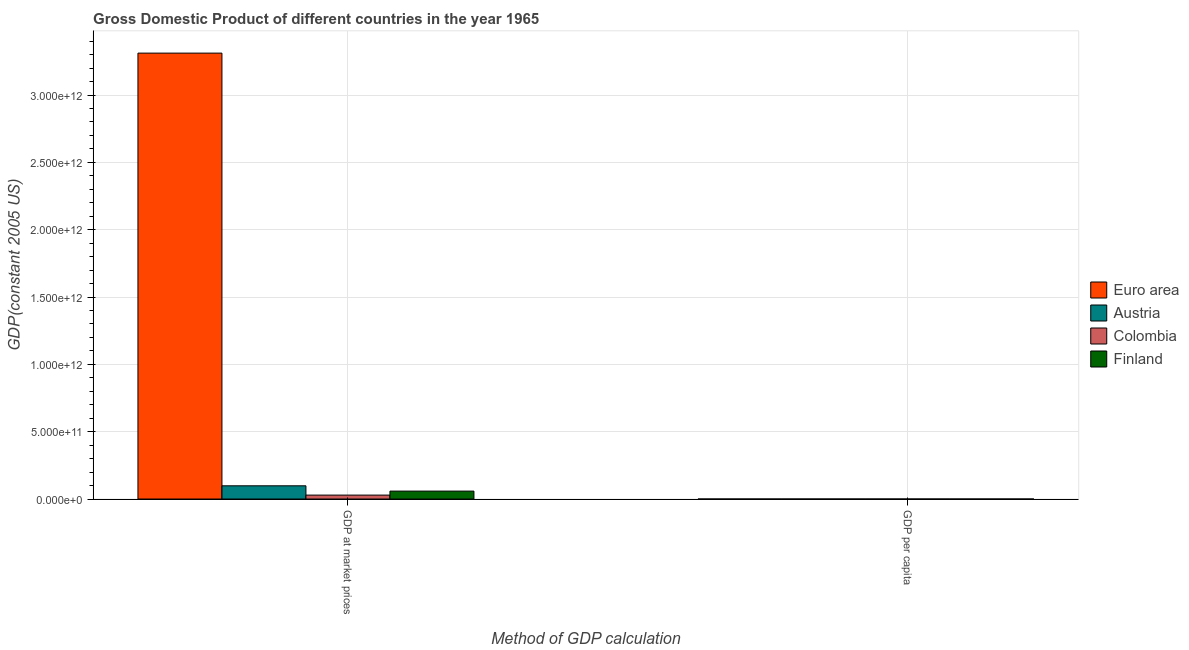Are the number of bars on each tick of the X-axis equal?
Your response must be concise. Yes. How many bars are there on the 1st tick from the left?
Your answer should be compact. 4. What is the label of the 2nd group of bars from the left?
Offer a very short reply. GDP per capita. What is the gdp per capita in Austria?
Keep it short and to the point. 1.35e+04. Across all countries, what is the maximum gdp per capita?
Provide a succinct answer. 1.35e+04. Across all countries, what is the minimum gdp per capita?
Make the answer very short. 1523.6. In which country was the gdp at market prices maximum?
Make the answer very short. Euro area. In which country was the gdp per capita minimum?
Make the answer very short. Colombia. What is the total gdp at market prices in the graph?
Ensure brevity in your answer.  3.50e+12. What is the difference between the gdp at market prices in Austria and that in Colombia?
Provide a short and direct response. 6.91e+1. What is the difference between the gdp at market prices in Colombia and the gdp per capita in Finland?
Provide a succinct answer. 2.92e+1. What is the average gdp per capita per country?
Your response must be concise. 9963.43. What is the difference between the gdp at market prices and gdp per capita in Austria?
Provide a succinct answer. 9.83e+1. What is the ratio of the gdp per capita in Euro area to that in Austria?
Your answer should be compact. 0.88. In how many countries, is the gdp per capita greater than the average gdp per capita taken over all countries?
Make the answer very short. 3. What does the 3rd bar from the left in GDP at market prices represents?
Ensure brevity in your answer.  Colombia. What does the 1st bar from the right in GDP per capita represents?
Provide a short and direct response. Finland. How many bars are there?
Provide a succinct answer. 8. How many countries are there in the graph?
Provide a short and direct response. 4. What is the difference between two consecutive major ticks on the Y-axis?
Offer a terse response. 5.00e+11. Does the graph contain grids?
Provide a short and direct response. Yes. Where does the legend appear in the graph?
Your answer should be very brief. Center right. How many legend labels are there?
Your answer should be compact. 4. How are the legend labels stacked?
Keep it short and to the point. Vertical. What is the title of the graph?
Your answer should be very brief. Gross Domestic Product of different countries in the year 1965. What is the label or title of the X-axis?
Your answer should be very brief. Method of GDP calculation. What is the label or title of the Y-axis?
Provide a short and direct response. GDP(constant 2005 US). What is the GDP(constant 2005 US) of Euro area in GDP at market prices?
Provide a short and direct response. 3.31e+12. What is the GDP(constant 2005 US) of Austria in GDP at market prices?
Keep it short and to the point. 9.83e+1. What is the GDP(constant 2005 US) of Colombia in GDP at market prices?
Make the answer very short. 2.92e+1. What is the GDP(constant 2005 US) of Finland in GDP at market prices?
Make the answer very short. 5.89e+1. What is the GDP(constant 2005 US) in Euro area in GDP per capita?
Offer a very short reply. 1.19e+04. What is the GDP(constant 2005 US) in Austria in GDP per capita?
Provide a short and direct response. 1.35e+04. What is the GDP(constant 2005 US) in Colombia in GDP per capita?
Make the answer very short. 1523.6. What is the GDP(constant 2005 US) in Finland in GDP per capita?
Offer a very short reply. 1.29e+04. Across all Method of GDP calculation, what is the maximum GDP(constant 2005 US) in Euro area?
Provide a short and direct response. 3.31e+12. Across all Method of GDP calculation, what is the maximum GDP(constant 2005 US) of Austria?
Your answer should be compact. 9.83e+1. Across all Method of GDP calculation, what is the maximum GDP(constant 2005 US) of Colombia?
Give a very brief answer. 2.92e+1. Across all Method of GDP calculation, what is the maximum GDP(constant 2005 US) of Finland?
Offer a terse response. 5.89e+1. Across all Method of GDP calculation, what is the minimum GDP(constant 2005 US) in Euro area?
Your answer should be compact. 1.19e+04. Across all Method of GDP calculation, what is the minimum GDP(constant 2005 US) in Austria?
Keep it short and to the point. 1.35e+04. Across all Method of GDP calculation, what is the minimum GDP(constant 2005 US) in Colombia?
Ensure brevity in your answer.  1523.6. Across all Method of GDP calculation, what is the minimum GDP(constant 2005 US) in Finland?
Offer a terse response. 1.29e+04. What is the total GDP(constant 2005 US) of Euro area in the graph?
Your response must be concise. 3.31e+12. What is the total GDP(constant 2005 US) in Austria in the graph?
Your response must be concise. 9.83e+1. What is the total GDP(constant 2005 US) in Colombia in the graph?
Offer a very short reply. 2.92e+1. What is the total GDP(constant 2005 US) of Finland in the graph?
Your answer should be very brief. 5.89e+1. What is the difference between the GDP(constant 2005 US) in Euro area in GDP at market prices and that in GDP per capita?
Provide a short and direct response. 3.31e+12. What is the difference between the GDP(constant 2005 US) of Austria in GDP at market prices and that in GDP per capita?
Your answer should be compact. 9.83e+1. What is the difference between the GDP(constant 2005 US) in Colombia in GDP at market prices and that in GDP per capita?
Offer a very short reply. 2.92e+1. What is the difference between the GDP(constant 2005 US) in Finland in GDP at market prices and that in GDP per capita?
Provide a succinct answer. 5.89e+1. What is the difference between the GDP(constant 2005 US) in Euro area in GDP at market prices and the GDP(constant 2005 US) in Austria in GDP per capita?
Give a very brief answer. 3.31e+12. What is the difference between the GDP(constant 2005 US) of Euro area in GDP at market prices and the GDP(constant 2005 US) of Colombia in GDP per capita?
Your response must be concise. 3.31e+12. What is the difference between the GDP(constant 2005 US) in Euro area in GDP at market prices and the GDP(constant 2005 US) in Finland in GDP per capita?
Keep it short and to the point. 3.31e+12. What is the difference between the GDP(constant 2005 US) in Austria in GDP at market prices and the GDP(constant 2005 US) in Colombia in GDP per capita?
Your answer should be compact. 9.83e+1. What is the difference between the GDP(constant 2005 US) of Austria in GDP at market prices and the GDP(constant 2005 US) of Finland in GDP per capita?
Offer a terse response. 9.83e+1. What is the difference between the GDP(constant 2005 US) of Colombia in GDP at market prices and the GDP(constant 2005 US) of Finland in GDP per capita?
Offer a terse response. 2.92e+1. What is the average GDP(constant 2005 US) in Euro area per Method of GDP calculation?
Offer a terse response. 1.66e+12. What is the average GDP(constant 2005 US) in Austria per Method of GDP calculation?
Your response must be concise. 4.91e+1. What is the average GDP(constant 2005 US) in Colombia per Method of GDP calculation?
Provide a succinct answer. 1.46e+1. What is the average GDP(constant 2005 US) in Finland per Method of GDP calculation?
Provide a short and direct response. 2.94e+1. What is the difference between the GDP(constant 2005 US) in Euro area and GDP(constant 2005 US) in Austria in GDP at market prices?
Your response must be concise. 3.21e+12. What is the difference between the GDP(constant 2005 US) of Euro area and GDP(constant 2005 US) of Colombia in GDP at market prices?
Your response must be concise. 3.28e+12. What is the difference between the GDP(constant 2005 US) of Euro area and GDP(constant 2005 US) of Finland in GDP at market prices?
Your answer should be compact. 3.25e+12. What is the difference between the GDP(constant 2005 US) in Austria and GDP(constant 2005 US) in Colombia in GDP at market prices?
Make the answer very short. 6.91e+1. What is the difference between the GDP(constant 2005 US) in Austria and GDP(constant 2005 US) in Finland in GDP at market prices?
Provide a short and direct response. 3.94e+1. What is the difference between the GDP(constant 2005 US) in Colombia and GDP(constant 2005 US) in Finland in GDP at market prices?
Offer a very short reply. -2.97e+1. What is the difference between the GDP(constant 2005 US) of Euro area and GDP(constant 2005 US) of Austria in GDP per capita?
Offer a very short reply. -1597.52. What is the difference between the GDP(constant 2005 US) in Euro area and GDP(constant 2005 US) in Colombia in GDP per capita?
Make the answer very short. 1.04e+04. What is the difference between the GDP(constant 2005 US) in Euro area and GDP(constant 2005 US) in Finland in GDP per capita?
Offer a very short reply. -984.12. What is the difference between the GDP(constant 2005 US) of Austria and GDP(constant 2005 US) of Colombia in GDP per capita?
Offer a very short reply. 1.20e+04. What is the difference between the GDP(constant 2005 US) of Austria and GDP(constant 2005 US) of Finland in GDP per capita?
Keep it short and to the point. 613.4. What is the difference between the GDP(constant 2005 US) in Colombia and GDP(constant 2005 US) in Finland in GDP per capita?
Your answer should be compact. -1.14e+04. What is the ratio of the GDP(constant 2005 US) of Euro area in GDP at market prices to that in GDP per capita?
Make the answer very short. 2.78e+08. What is the ratio of the GDP(constant 2005 US) of Austria in GDP at market prices to that in GDP per capita?
Make the answer very short. 7.27e+06. What is the ratio of the GDP(constant 2005 US) in Colombia in GDP at market prices to that in GDP per capita?
Your answer should be compact. 1.91e+07. What is the ratio of the GDP(constant 2005 US) in Finland in GDP at market prices to that in GDP per capita?
Your answer should be very brief. 4.56e+06. What is the difference between the highest and the second highest GDP(constant 2005 US) of Euro area?
Your response must be concise. 3.31e+12. What is the difference between the highest and the second highest GDP(constant 2005 US) in Austria?
Offer a very short reply. 9.83e+1. What is the difference between the highest and the second highest GDP(constant 2005 US) of Colombia?
Keep it short and to the point. 2.92e+1. What is the difference between the highest and the second highest GDP(constant 2005 US) in Finland?
Your answer should be very brief. 5.89e+1. What is the difference between the highest and the lowest GDP(constant 2005 US) in Euro area?
Provide a succinct answer. 3.31e+12. What is the difference between the highest and the lowest GDP(constant 2005 US) in Austria?
Provide a succinct answer. 9.83e+1. What is the difference between the highest and the lowest GDP(constant 2005 US) in Colombia?
Ensure brevity in your answer.  2.92e+1. What is the difference between the highest and the lowest GDP(constant 2005 US) of Finland?
Provide a succinct answer. 5.89e+1. 